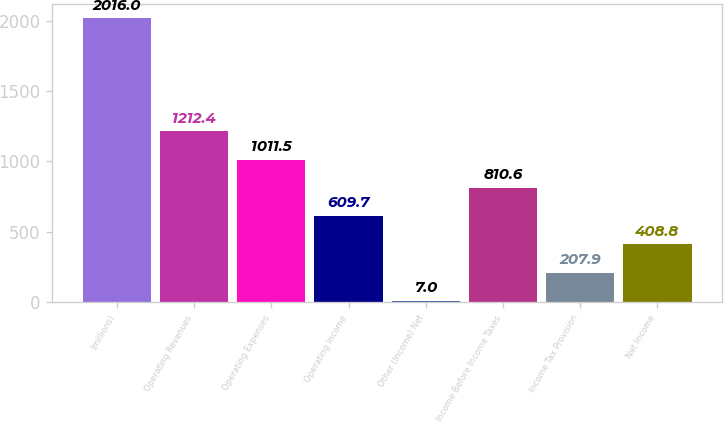Convert chart to OTSL. <chart><loc_0><loc_0><loc_500><loc_500><bar_chart><fcel>(millions)<fcel>Operating Revenues<fcel>Operating Expenses<fcel>Operating Income<fcel>Other (Income) Net<fcel>Income Before Income Taxes<fcel>Income Tax Provision<fcel>Net Income<nl><fcel>2016<fcel>1212.4<fcel>1011.5<fcel>609.7<fcel>7<fcel>810.6<fcel>207.9<fcel>408.8<nl></chart> 